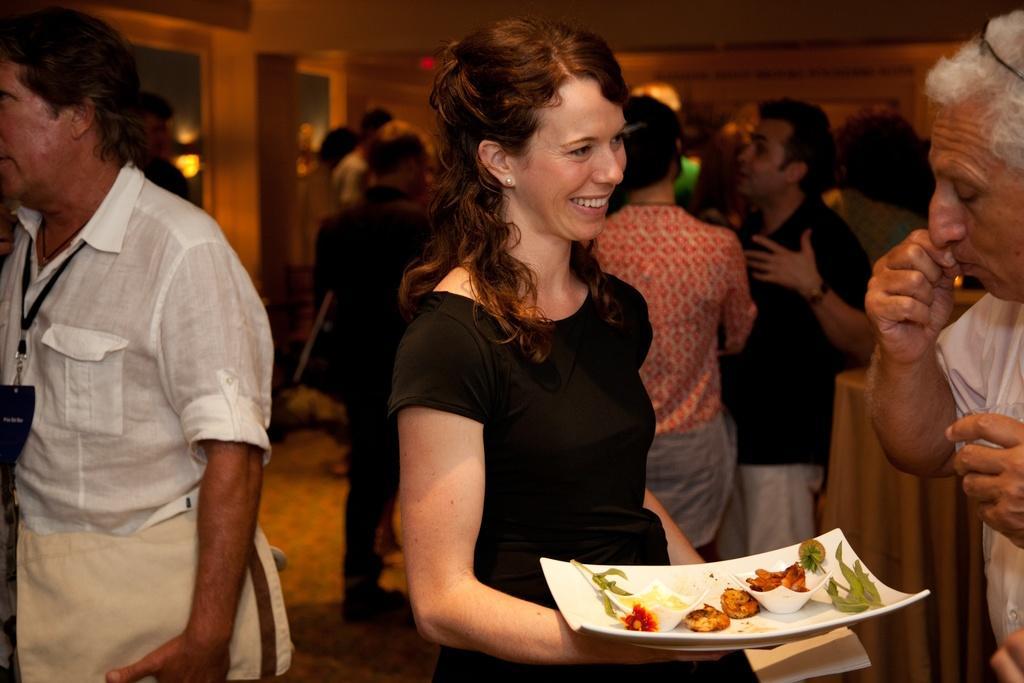How would you summarize this image in a sentence or two? In this image I can see there are groups of people standing inside the house. And there are chairs, Window and table. On the table there is a cloth. And the person holding a paper and plate. On the plate there is a bowl and some food items and there are some leaves. 